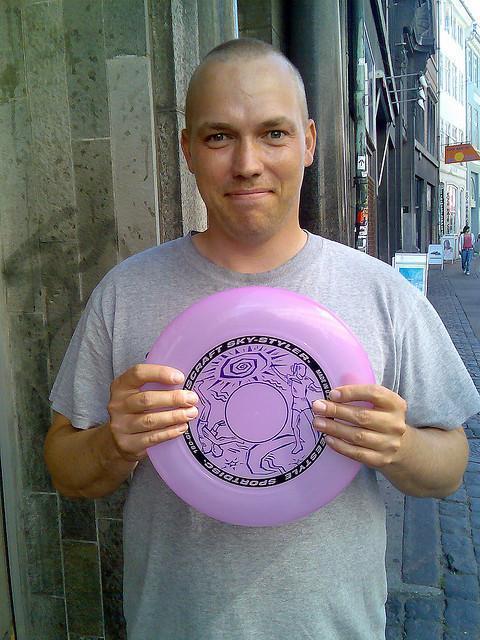This frisbee is how many grams?
Choose the correct response and explain in the format: 'Answer: answer
Rationale: rationale.'
Options: 200, 300, 160, 250. Answer: 160.
Rationale: Frisbees are really light so they can fly in the air. 